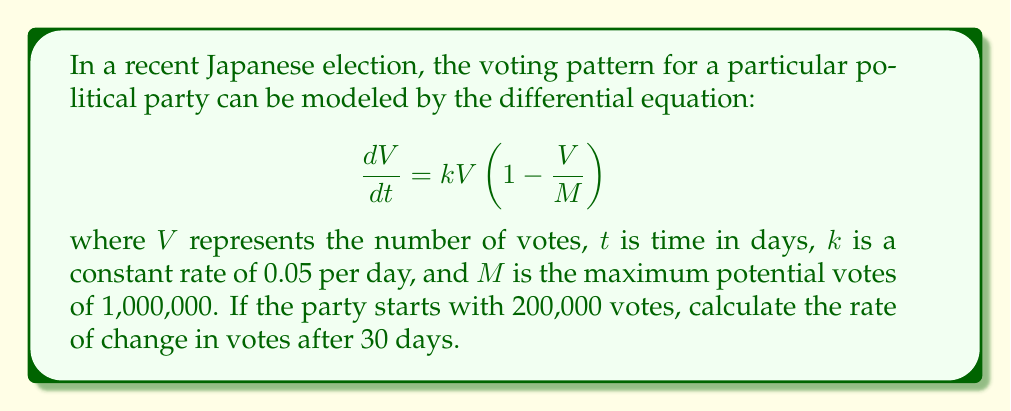Provide a solution to this math problem. To solve this problem, we'll follow these steps:

1) First, we need to solve the differential equation to find $V(t)$. This is a logistic growth equation with solution:

   $$V(t) = \frac{M}{1 + (\frac{M}{V_0} - 1)e^{-kt}}$$

   where $V_0$ is the initial number of votes.

2) We're given:
   $M = 1,000,000$
   $k = 0.05$
   $V_0 = 200,000$
   $t = 30$

3) Let's substitute these values into our solution:

   $$V(30) = \frac{1,000,000}{1 + (\frac{1,000,000}{200,000} - 1)e^{-0.05(30)}}$$

4) Simplify:
   $$V(30) = \frac{1,000,000}{1 + 4e^{-1.5}} \approx 431,233$$

5) Now that we have $V(30)$, we can calculate the rate of change at $t=30$ by plugging this back into our original differential equation:

   $$\frac{dV}{dt} = kV(1-\frac{V}{M})$$

6) Substitute the values:

   $$\frac{dV}{dt} = 0.05(431,233)(1-\frac{431,233}{1,000,000})$$

7) Solve:

   $$\frac{dV}{dt} = 21,561.65(0.568767) \approx 12,263$$

Thus, after 30 days, the rate of change in votes is approximately 12,263 votes per day.
Answer: 12,263 votes/day 